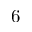Convert formula to latex. <formula><loc_0><loc_0><loc_500><loc_500>6</formula> 